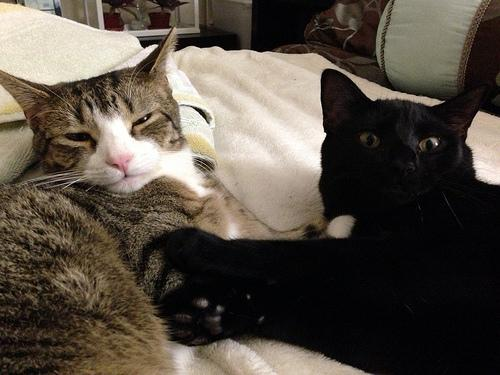Question: how many cats are shown?
Choices:
A. One.
B. None.
C. Three.
D. Two.
Answer with the letter. Answer: D Question: what are the cats doing?
Choices:
A. Laying.
B. Playing.
C. Eating.
D. Mating.
Answer with the letter. Answer: A Question: where are the cats laying?
Choices:
A. Floor.
B. Under a bush.
C. Atop a car.
D. Bed.
Answer with the letter. Answer: D Question: why are the cats laying?
Choices:
A. Sleepy.
B. Hunting.
C. Looking for friends.
D. To eat.
Answer with the letter. Answer: A Question: who took the cats picture?
Choices:
A. Family friend.
B. Professional photographer.
C. Owner.
D. The dog.
Answer with the letter. Answer: C Question: where was this picture taken?
Choices:
A. Kitchen.
B. Bathroom.
C. Library.
D. Bedroom.
Answer with the letter. Answer: D 